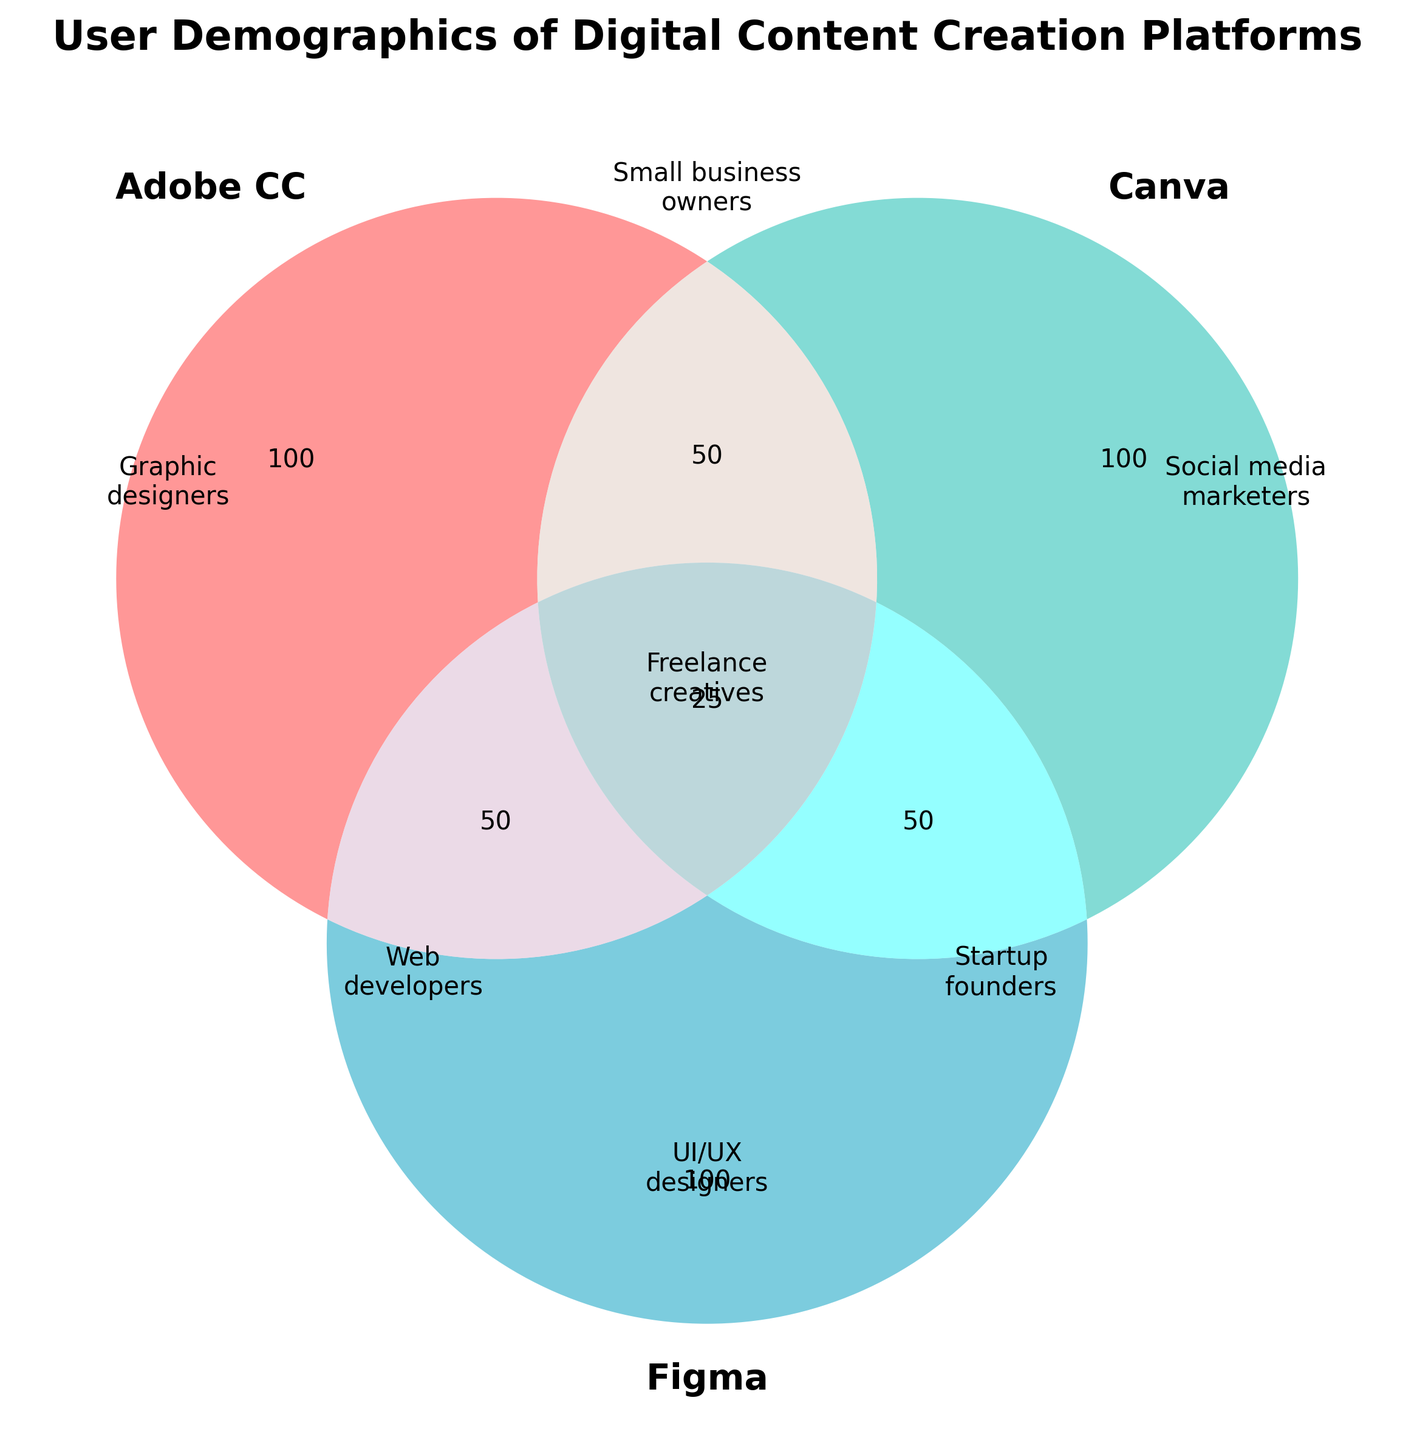What's the title of the figure? The title is usually placed at the top, and it summarizes the content of the figure. It is written as "User Demographics of Digital Content Creation Platforms" at the top.
Answer: User Demographics of Digital Content Creation Platforms Which platform is associated with Graphic designers? To find this, look at the section labeled "Graphic designers." It's within the circle representing "Adobe CC."
Answer: Adobe Creative Cloud Who are the users that intersect between Adobe Creative Cloud and Canva? Look for the section where the circles for "Adobe CC" and "Canva" overlap. The label there is "Small business owners."
Answer: Small business owners How many user groups are represented in the intersection of all three platforms? Observe the center where all three circles (Adobe CC, Canva, and Figma) overlap. The label is "Freelance creatives."
Answer: One (Freelance creatives) Which platform has UI/UX designers as its primary users? Look at the section labeled "UI/UX designers," which is within the circle representing "Figma."
Answer: Figma What type of users do Startup founders represent in terms of platform overlap? To find this, check the section where Canva and Figma circles overlap without Adobe CC. It's labeled "Startup founders."
Answer: Canva and Figma Who are the users in the intersection of Adobe Creative Cloud and Figma? The section where "Adobe CC" and "Figma" circles overlap is labeled "Web developers."
Answer: Web developers Do any user types span all three platforms? Look at the center of the Venn diagram where all three circles intersect. The label is "Freelance creatives," indicating users who use all three platforms.
Answer: Yes, Freelance creatives Which platform does not have unique user groups labeled outside intersections? Since all the sections have labels and there's no exclusively labeled section for Canva and Figma, both platforms share users in intersections.
Answer: None 